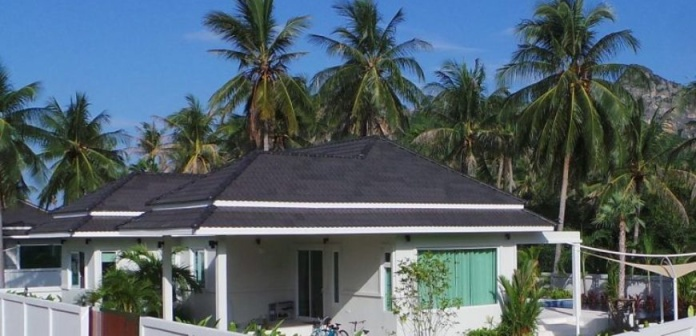What details can you tell me about the architectural style of the bungalow? The bungalow exhibits a modern tropical architectural style characterized by its clean lines and simple form. The structure features a prominent roof with wide eaves that provide shade and protection from the tropical weather. The green shutters are not only functional for ventilation and privacy but also add an aesthetic touch that complements the lush, green surroundings. The overall design is both functional and visually appealing, aligning well with its tropical setting. 